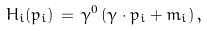<formula> <loc_0><loc_0><loc_500><loc_500>H _ { i } ( p _ { i } ) \, = \, \gamma ^ { 0 } \, ( \gamma \cdot p _ { i } + m _ { i } ) \, ,</formula> 